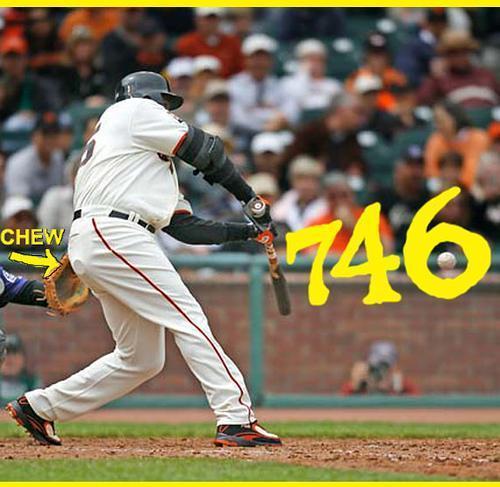How many people are visible?
Give a very brief answer. 11. 